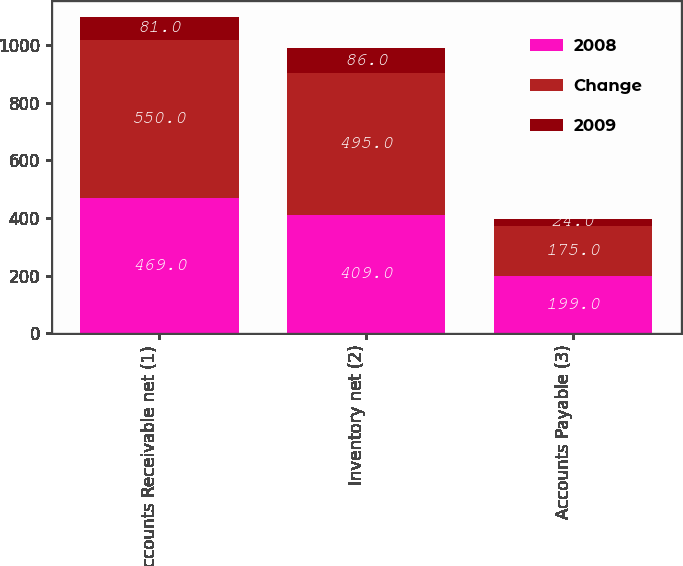Convert chart to OTSL. <chart><loc_0><loc_0><loc_500><loc_500><stacked_bar_chart><ecel><fcel>Accounts Receivable net (1)<fcel>Inventory net (2)<fcel>Accounts Payable (3)<nl><fcel>2008<fcel>469<fcel>409<fcel>199<nl><fcel>Change<fcel>550<fcel>495<fcel>175<nl><fcel>2009<fcel>81<fcel>86<fcel>24<nl></chart> 